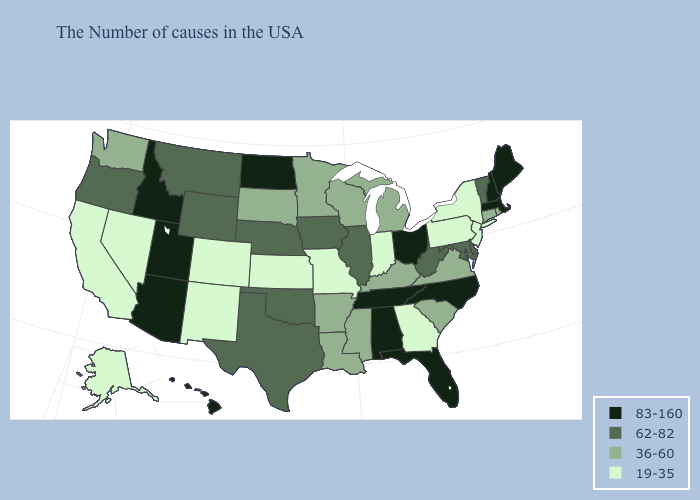What is the value of California?
Keep it brief. 19-35. What is the lowest value in the USA?
Give a very brief answer. 19-35. Among the states that border Oregon , which have the lowest value?
Answer briefly. Nevada, California. Name the states that have a value in the range 62-82?
Short answer required. Vermont, Delaware, Maryland, West Virginia, Illinois, Iowa, Nebraska, Oklahoma, Texas, Wyoming, Montana, Oregon. What is the lowest value in the MidWest?
Write a very short answer. 19-35. What is the value of West Virginia?
Short answer required. 62-82. Name the states that have a value in the range 19-35?
Give a very brief answer. New York, New Jersey, Pennsylvania, Georgia, Indiana, Missouri, Kansas, Colorado, New Mexico, Nevada, California, Alaska. How many symbols are there in the legend?
Short answer required. 4. Among the states that border Arkansas , does Tennessee have the highest value?
Be succinct. Yes. Does Maine have the same value as Vermont?
Quick response, please. No. What is the value of Wisconsin?
Answer briefly. 36-60. Among the states that border Oklahoma , does Texas have the highest value?
Quick response, please. Yes. What is the highest value in the Northeast ?
Keep it brief. 83-160. Among the states that border Michigan , which have the lowest value?
Quick response, please. Indiana. What is the value of Wyoming?
Answer briefly. 62-82. 